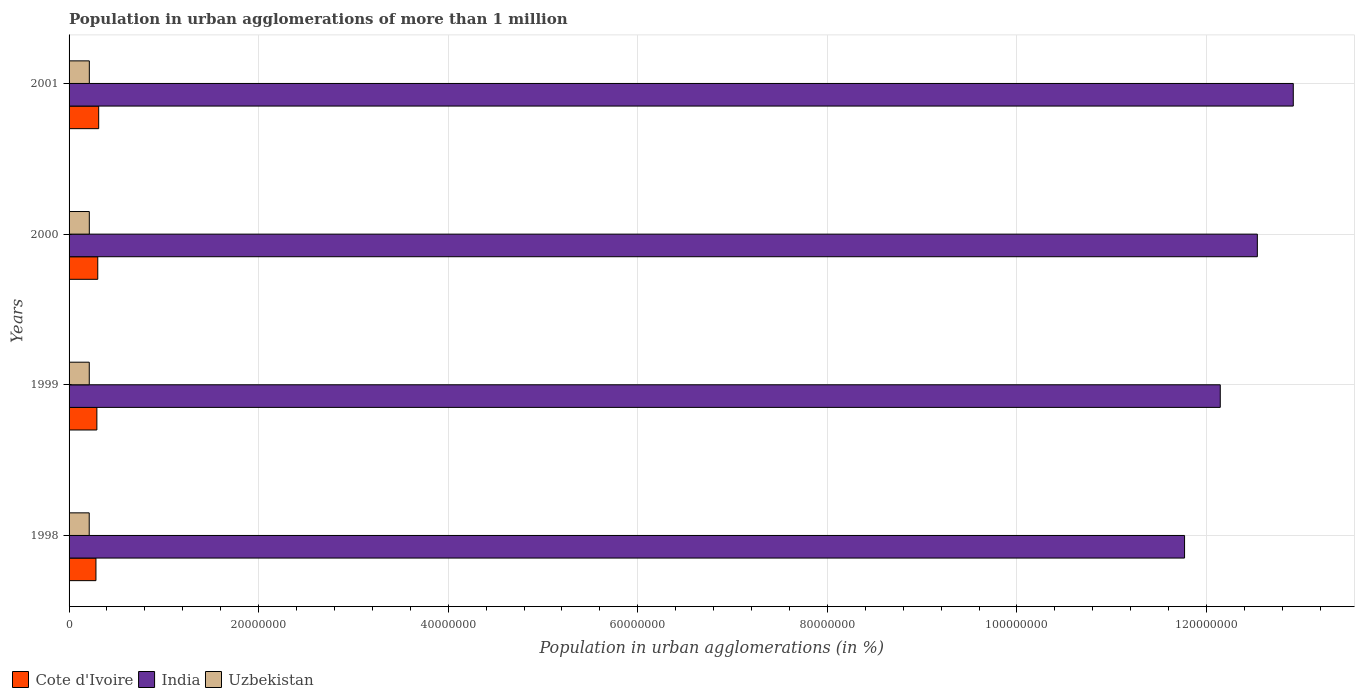How many different coloured bars are there?
Offer a terse response. 3. Are the number of bars per tick equal to the number of legend labels?
Your answer should be compact. Yes. How many bars are there on the 3rd tick from the top?
Your response must be concise. 3. How many bars are there on the 3rd tick from the bottom?
Provide a succinct answer. 3. What is the population in urban agglomerations in India in 2001?
Your answer should be very brief. 1.29e+08. Across all years, what is the maximum population in urban agglomerations in India?
Keep it short and to the point. 1.29e+08. Across all years, what is the minimum population in urban agglomerations in Uzbekistan?
Make the answer very short. 2.13e+06. In which year was the population in urban agglomerations in India minimum?
Your answer should be compact. 1998. What is the total population in urban agglomerations in Uzbekistan in the graph?
Your response must be concise. 8.53e+06. What is the difference between the population in urban agglomerations in Uzbekistan in 1999 and that in 2001?
Ensure brevity in your answer.  -6581. What is the difference between the population in urban agglomerations in India in 1998 and the population in urban agglomerations in Uzbekistan in 1999?
Offer a very short reply. 1.16e+08. What is the average population in urban agglomerations in India per year?
Your answer should be compact. 1.23e+08. In the year 2001, what is the difference between the population in urban agglomerations in India and population in urban agglomerations in Uzbekistan?
Your response must be concise. 1.27e+08. What is the ratio of the population in urban agglomerations in Cote d'Ivoire in 1999 to that in 2001?
Ensure brevity in your answer.  0.94. Is the population in urban agglomerations in Uzbekistan in 1999 less than that in 2001?
Your answer should be compact. Yes. What is the difference between the highest and the second highest population in urban agglomerations in Cote d'Ivoire?
Keep it short and to the point. 9.69e+04. What is the difference between the highest and the lowest population in urban agglomerations in India?
Your response must be concise. 1.15e+07. What does the 3rd bar from the top in 1998 represents?
Your answer should be very brief. Cote d'Ivoire. What does the 1st bar from the bottom in 1998 represents?
Ensure brevity in your answer.  Cote d'Ivoire. Is it the case that in every year, the sum of the population in urban agglomerations in India and population in urban agglomerations in Uzbekistan is greater than the population in urban agglomerations in Cote d'Ivoire?
Keep it short and to the point. Yes. How many bars are there?
Make the answer very short. 12. Are all the bars in the graph horizontal?
Offer a terse response. Yes. Where does the legend appear in the graph?
Your response must be concise. Bottom left. What is the title of the graph?
Your response must be concise. Population in urban agglomerations of more than 1 million. What is the label or title of the X-axis?
Make the answer very short. Population in urban agglomerations (in %). What is the Population in urban agglomerations (in %) of Cote d'Ivoire in 1998?
Keep it short and to the point. 2.84e+06. What is the Population in urban agglomerations (in %) of India in 1998?
Your answer should be compact. 1.18e+08. What is the Population in urban agglomerations (in %) in Uzbekistan in 1998?
Ensure brevity in your answer.  2.13e+06. What is the Population in urban agglomerations (in %) of Cote d'Ivoire in 1999?
Your answer should be compact. 2.93e+06. What is the Population in urban agglomerations (in %) in India in 1999?
Your answer should be compact. 1.21e+08. What is the Population in urban agglomerations (in %) in Uzbekistan in 1999?
Your answer should be compact. 2.13e+06. What is the Population in urban agglomerations (in %) in Cote d'Ivoire in 2000?
Give a very brief answer. 3.03e+06. What is the Population in urban agglomerations (in %) of India in 2000?
Provide a succinct answer. 1.25e+08. What is the Population in urban agglomerations (in %) in Uzbekistan in 2000?
Your answer should be compact. 2.13e+06. What is the Population in urban agglomerations (in %) of Cote d'Ivoire in 2001?
Ensure brevity in your answer.  3.12e+06. What is the Population in urban agglomerations (in %) in India in 2001?
Your answer should be compact. 1.29e+08. What is the Population in urban agglomerations (in %) in Uzbekistan in 2001?
Your answer should be compact. 2.14e+06. Across all years, what is the maximum Population in urban agglomerations (in %) of Cote d'Ivoire?
Give a very brief answer. 3.12e+06. Across all years, what is the maximum Population in urban agglomerations (in %) of India?
Make the answer very short. 1.29e+08. Across all years, what is the maximum Population in urban agglomerations (in %) in Uzbekistan?
Offer a terse response. 2.14e+06. Across all years, what is the minimum Population in urban agglomerations (in %) in Cote d'Ivoire?
Make the answer very short. 2.84e+06. Across all years, what is the minimum Population in urban agglomerations (in %) of India?
Offer a terse response. 1.18e+08. Across all years, what is the minimum Population in urban agglomerations (in %) in Uzbekistan?
Ensure brevity in your answer.  2.13e+06. What is the total Population in urban agglomerations (in %) of Cote d'Ivoire in the graph?
Offer a terse response. 1.19e+07. What is the total Population in urban agglomerations (in %) of India in the graph?
Ensure brevity in your answer.  4.94e+08. What is the total Population in urban agglomerations (in %) of Uzbekistan in the graph?
Your response must be concise. 8.53e+06. What is the difference between the Population in urban agglomerations (in %) in Cote d'Ivoire in 1998 and that in 1999?
Make the answer very short. -9.76e+04. What is the difference between the Population in urban agglomerations (in %) of India in 1998 and that in 1999?
Offer a terse response. -3.77e+06. What is the difference between the Population in urban agglomerations (in %) of Uzbekistan in 1998 and that in 1999?
Offer a very short reply. -5273. What is the difference between the Population in urban agglomerations (in %) of Cote d'Ivoire in 1998 and that in 2000?
Give a very brief answer. -1.92e+05. What is the difference between the Population in urban agglomerations (in %) of India in 1998 and that in 2000?
Your answer should be compact. -7.68e+06. What is the difference between the Population in urban agglomerations (in %) in Uzbekistan in 1998 and that in 2000?
Make the answer very short. -9238. What is the difference between the Population in urban agglomerations (in %) of Cote d'Ivoire in 1998 and that in 2001?
Your response must be concise. -2.89e+05. What is the difference between the Population in urban agglomerations (in %) in India in 1998 and that in 2001?
Provide a short and direct response. -1.15e+07. What is the difference between the Population in urban agglomerations (in %) of Uzbekistan in 1998 and that in 2001?
Keep it short and to the point. -1.19e+04. What is the difference between the Population in urban agglomerations (in %) in Cote d'Ivoire in 1999 and that in 2000?
Give a very brief answer. -9.41e+04. What is the difference between the Population in urban agglomerations (in %) of India in 1999 and that in 2000?
Provide a short and direct response. -3.91e+06. What is the difference between the Population in urban agglomerations (in %) of Uzbekistan in 1999 and that in 2000?
Keep it short and to the point. -3965. What is the difference between the Population in urban agglomerations (in %) of Cote d'Ivoire in 1999 and that in 2001?
Provide a short and direct response. -1.91e+05. What is the difference between the Population in urban agglomerations (in %) in India in 1999 and that in 2001?
Offer a very short reply. -7.70e+06. What is the difference between the Population in urban agglomerations (in %) of Uzbekistan in 1999 and that in 2001?
Provide a succinct answer. -6581. What is the difference between the Population in urban agglomerations (in %) in Cote d'Ivoire in 2000 and that in 2001?
Offer a very short reply. -9.69e+04. What is the difference between the Population in urban agglomerations (in %) in India in 2000 and that in 2001?
Offer a terse response. -3.79e+06. What is the difference between the Population in urban agglomerations (in %) in Uzbekistan in 2000 and that in 2001?
Your answer should be compact. -2616. What is the difference between the Population in urban agglomerations (in %) of Cote d'Ivoire in 1998 and the Population in urban agglomerations (in %) of India in 1999?
Make the answer very short. -1.19e+08. What is the difference between the Population in urban agglomerations (in %) of Cote d'Ivoire in 1998 and the Population in urban agglomerations (in %) of Uzbekistan in 1999?
Make the answer very short. 7.05e+05. What is the difference between the Population in urban agglomerations (in %) in India in 1998 and the Population in urban agglomerations (in %) in Uzbekistan in 1999?
Make the answer very short. 1.16e+08. What is the difference between the Population in urban agglomerations (in %) of Cote d'Ivoire in 1998 and the Population in urban agglomerations (in %) of India in 2000?
Offer a very short reply. -1.23e+08. What is the difference between the Population in urban agglomerations (in %) of Cote d'Ivoire in 1998 and the Population in urban agglomerations (in %) of Uzbekistan in 2000?
Your response must be concise. 7.01e+05. What is the difference between the Population in urban agglomerations (in %) in India in 1998 and the Population in urban agglomerations (in %) in Uzbekistan in 2000?
Your answer should be compact. 1.16e+08. What is the difference between the Population in urban agglomerations (in %) in Cote d'Ivoire in 1998 and the Population in urban agglomerations (in %) in India in 2001?
Provide a short and direct response. -1.26e+08. What is the difference between the Population in urban agglomerations (in %) of Cote d'Ivoire in 1998 and the Population in urban agglomerations (in %) of Uzbekistan in 2001?
Offer a terse response. 6.99e+05. What is the difference between the Population in urban agglomerations (in %) of India in 1998 and the Population in urban agglomerations (in %) of Uzbekistan in 2001?
Your answer should be compact. 1.16e+08. What is the difference between the Population in urban agglomerations (in %) of Cote d'Ivoire in 1999 and the Population in urban agglomerations (in %) of India in 2000?
Offer a very short reply. -1.22e+08. What is the difference between the Population in urban agglomerations (in %) of Cote d'Ivoire in 1999 and the Population in urban agglomerations (in %) of Uzbekistan in 2000?
Make the answer very short. 7.99e+05. What is the difference between the Population in urban agglomerations (in %) in India in 1999 and the Population in urban agglomerations (in %) in Uzbekistan in 2000?
Your answer should be very brief. 1.19e+08. What is the difference between the Population in urban agglomerations (in %) of Cote d'Ivoire in 1999 and the Population in urban agglomerations (in %) of India in 2001?
Offer a very short reply. -1.26e+08. What is the difference between the Population in urban agglomerations (in %) in Cote d'Ivoire in 1999 and the Population in urban agglomerations (in %) in Uzbekistan in 2001?
Your answer should be compact. 7.96e+05. What is the difference between the Population in urban agglomerations (in %) in India in 1999 and the Population in urban agglomerations (in %) in Uzbekistan in 2001?
Your answer should be very brief. 1.19e+08. What is the difference between the Population in urban agglomerations (in %) of Cote d'Ivoire in 2000 and the Population in urban agglomerations (in %) of India in 2001?
Offer a terse response. -1.26e+08. What is the difference between the Population in urban agglomerations (in %) of Cote d'Ivoire in 2000 and the Population in urban agglomerations (in %) of Uzbekistan in 2001?
Make the answer very short. 8.91e+05. What is the difference between the Population in urban agglomerations (in %) of India in 2000 and the Population in urban agglomerations (in %) of Uzbekistan in 2001?
Your answer should be very brief. 1.23e+08. What is the average Population in urban agglomerations (in %) of Cote d'Ivoire per year?
Offer a terse response. 2.98e+06. What is the average Population in urban agglomerations (in %) of India per year?
Your response must be concise. 1.23e+08. What is the average Population in urban agglomerations (in %) of Uzbekistan per year?
Your response must be concise. 2.13e+06. In the year 1998, what is the difference between the Population in urban agglomerations (in %) of Cote d'Ivoire and Population in urban agglomerations (in %) of India?
Offer a terse response. -1.15e+08. In the year 1998, what is the difference between the Population in urban agglomerations (in %) of Cote d'Ivoire and Population in urban agglomerations (in %) of Uzbekistan?
Your answer should be very brief. 7.11e+05. In the year 1998, what is the difference between the Population in urban agglomerations (in %) in India and Population in urban agglomerations (in %) in Uzbekistan?
Your answer should be compact. 1.16e+08. In the year 1999, what is the difference between the Population in urban agglomerations (in %) of Cote d'Ivoire and Population in urban agglomerations (in %) of India?
Make the answer very short. -1.19e+08. In the year 1999, what is the difference between the Population in urban agglomerations (in %) in Cote d'Ivoire and Population in urban agglomerations (in %) in Uzbekistan?
Give a very brief answer. 8.03e+05. In the year 1999, what is the difference between the Population in urban agglomerations (in %) of India and Population in urban agglomerations (in %) of Uzbekistan?
Provide a short and direct response. 1.19e+08. In the year 2000, what is the difference between the Population in urban agglomerations (in %) of Cote d'Ivoire and Population in urban agglomerations (in %) of India?
Keep it short and to the point. -1.22e+08. In the year 2000, what is the difference between the Population in urban agglomerations (in %) of Cote d'Ivoire and Population in urban agglomerations (in %) of Uzbekistan?
Your answer should be very brief. 8.93e+05. In the year 2000, what is the difference between the Population in urban agglomerations (in %) in India and Population in urban agglomerations (in %) in Uzbekistan?
Offer a terse response. 1.23e+08. In the year 2001, what is the difference between the Population in urban agglomerations (in %) of Cote d'Ivoire and Population in urban agglomerations (in %) of India?
Ensure brevity in your answer.  -1.26e+08. In the year 2001, what is the difference between the Population in urban agglomerations (in %) of Cote d'Ivoire and Population in urban agglomerations (in %) of Uzbekistan?
Offer a very short reply. 9.88e+05. In the year 2001, what is the difference between the Population in urban agglomerations (in %) of India and Population in urban agglomerations (in %) of Uzbekistan?
Your answer should be compact. 1.27e+08. What is the ratio of the Population in urban agglomerations (in %) of Cote d'Ivoire in 1998 to that in 1999?
Offer a very short reply. 0.97. What is the ratio of the Population in urban agglomerations (in %) of India in 1998 to that in 1999?
Make the answer very short. 0.97. What is the ratio of the Population in urban agglomerations (in %) in Cote d'Ivoire in 1998 to that in 2000?
Ensure brevity in your answer.  0.94. What is the ratio of the Population in urban agglomerations (in %) in India in 1998 to that in 2000?
Provide a short and direct response. 0.94. What is the ratio of the Population in urban agglomerations (in %) of Uzbekistan in 1998 to that in 2000?
Your answer should be compact. 1. What is the ratio of the Population in urban agglomerations (in %) in Cote d'Ivoire in 1998 to that in 2001?
Keep it short and to the point. 0.91. What is the ratio of the Population in urban agglomerations (in %) of India in 1998 to that in 2001?
Your answer should be compact. 0.91. What is the ratio of the Population in urban agglomerations (in %) in Cote d'Ivoire in 1999 to that in 2000?
Keep it short and to the point. 0.97. What is the ratio of the Population in urban agglomerations (in %) in India in 1999 to that in 2000?
Offer a terse response. 0.97. What is the ratio of the Population in urban agglomerations (in %) of Uzbekistan in 1999 to that in 2000?
Your answer should be very brief. 1. What is the ratio of the Population in urban agglomerations (in %) in Cote d'Ivoire in 1999 to that in 2001?
Your answer should be compact. 0.94. What is the ratio of the Population in urban agglomerations (in %) of India in 1999 to that in 2001?
Your answer should be very brief. 0.94. What is the ratio of the Population in urban agglomerations (in %) of Uzbekistan in 1999 to that in 2001?
Offer a terse response. 1. What is the ratio of the Population in urban agglomerations (in %) of Cote d'Ivoire in 2000 to that in 2001?
Make the answer very short. 0.97. What is the ratio of the Population in urban agglomerations (in %) of India in 2000 to that in 2001?
Provide a succinct answer. 0.97. What is the difference between the highest and the second highest Population in urban agglomerations (in %) of Cote d'Ivoire?
Offer a terse response. 9.69e+04. What is the difference between the highest and the second highest Population in urban agglomerations (in %) in India?
Your answer should be very brief. 3.79e+06. What is the difference between the highest and the second highest Population in urban agglomerations (in %) of Uzbekistan?
Keep it short and to the point. 2616. What is the difference between the highest and the lowest Population in urban agglomerations (in %) in Cote d'Ivoire?
Keep it short and to the point. 2.89e+05. What is the difference between the highest and the lowest Population in urban agglomerations (in %) of India?
Give a very brief answer. 1.15e+07. What is the difference between the highest and the lowest Population in urban agglomerations (in %) in Uzbekistan?
Ensure brevity in your answer.  1.19e+04. 